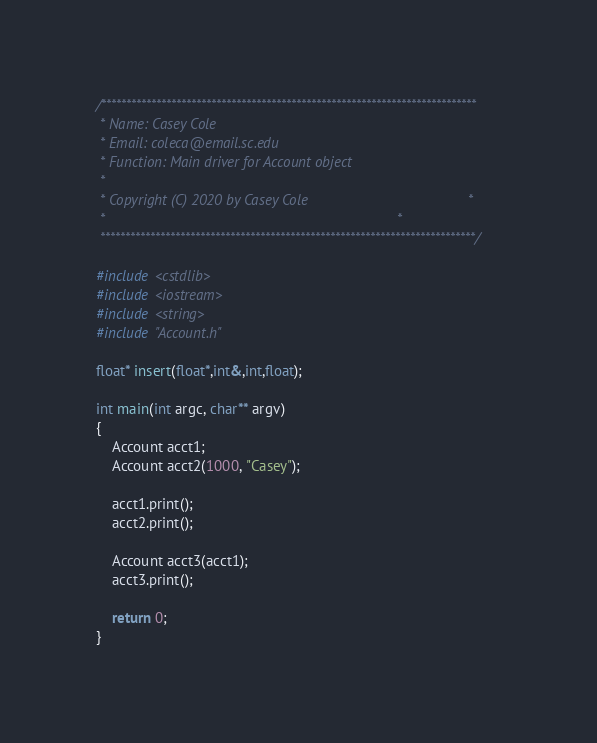Convert code to text. <code><loc_0><loc_0><loc_500><loc_500><_C++_>/***************************************************************************
 * Name: Casey Cole
 * Email: coleca@email.sc.edu
 * Function: Main driver for Account object
 * 
 * Copyright (C) 2020 by Casey Cole                                        *
 *                                                                         *
 ***************************************************************************/
 
#include <cstdlib>
#include <iostream>
#include <string>
#include "Account.h"

float* insert(float*,int&,int,float);

int main(int argc, char** argv) 
{
	Account acct1;
	Account acct2(1000, "Casey");
	
	acct1.print();
	acct2.print();
	
	Account acct3(acct1);
	acct3.print();

    return 0;
}
</code> 